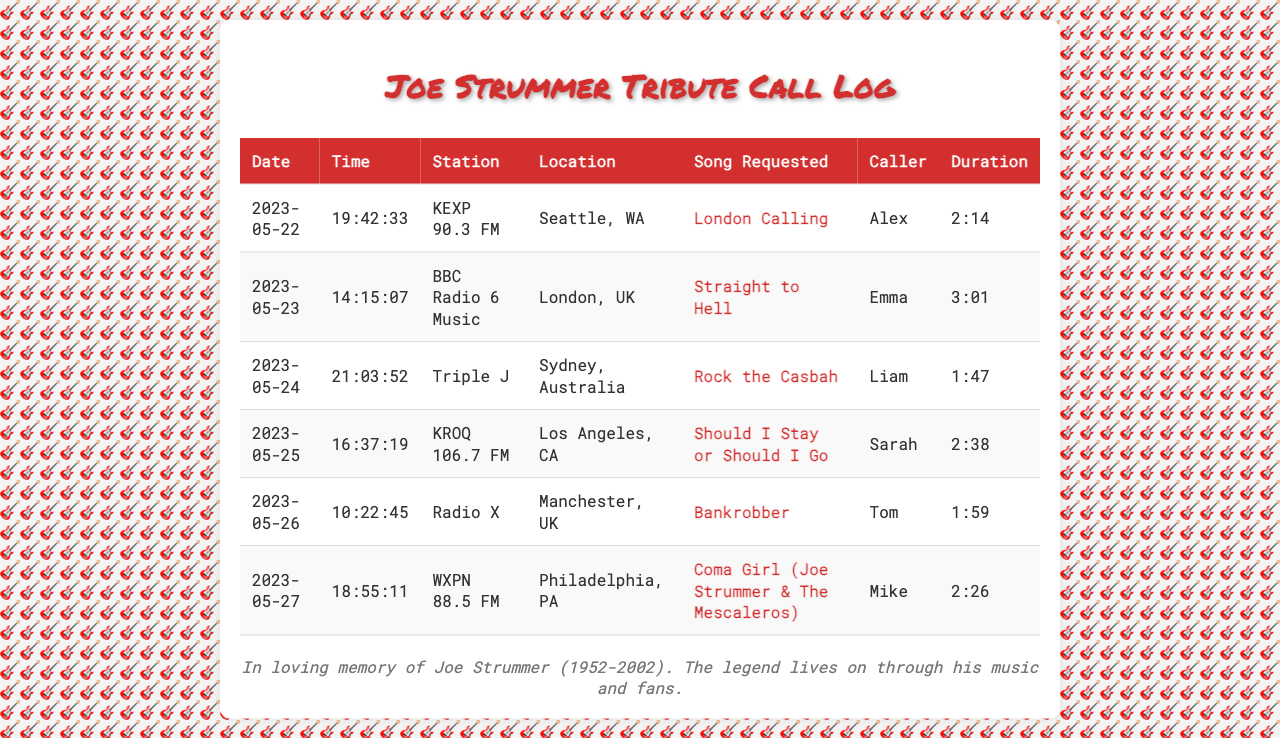What song was requested on May 22, 2023? The song requested on May 22, 2023, is listed in the corresponding row of the table.
Answer: London Calling Which radio station did Emma call on May 23, 2023? The radio station is found in Emma's row for that date.
Answer: BBC Radio 6 Music How long was the call made to KEXP 90.3 FM? The duration of the call to KEXP 90.3 FM is specified in the duration column of the table.
Answer: 2:14 Who was the caller requesting "Straight to Hell"? The caller's name is directly listed in the row for that song request.
Answer: Emma What location was associated with the request for "Coma Girl"? The location is found next to the entry for the request of "Coma Girl" in the table.
Answer: Philadelphia, PA Which song was requested from Triple J? The song requested from Triple J is detailed in the respective row of the document.
Answer: Rock the Casbah How many calls were made to radio stations in total? The total number of calls is equivalent to the number of rows in the table, which indicates each completed call entry.
Answer: 6 What was the date of the call requesting "Should I Stay or Should I Go"? The date can be found in the row corresponding to that specific song request.
Answer: 2023-05-25 Which caller requested the song "Bankrobber"? The caller's name for the song "Bankrobber" is found in the same row of the table.
Answer: Tom 